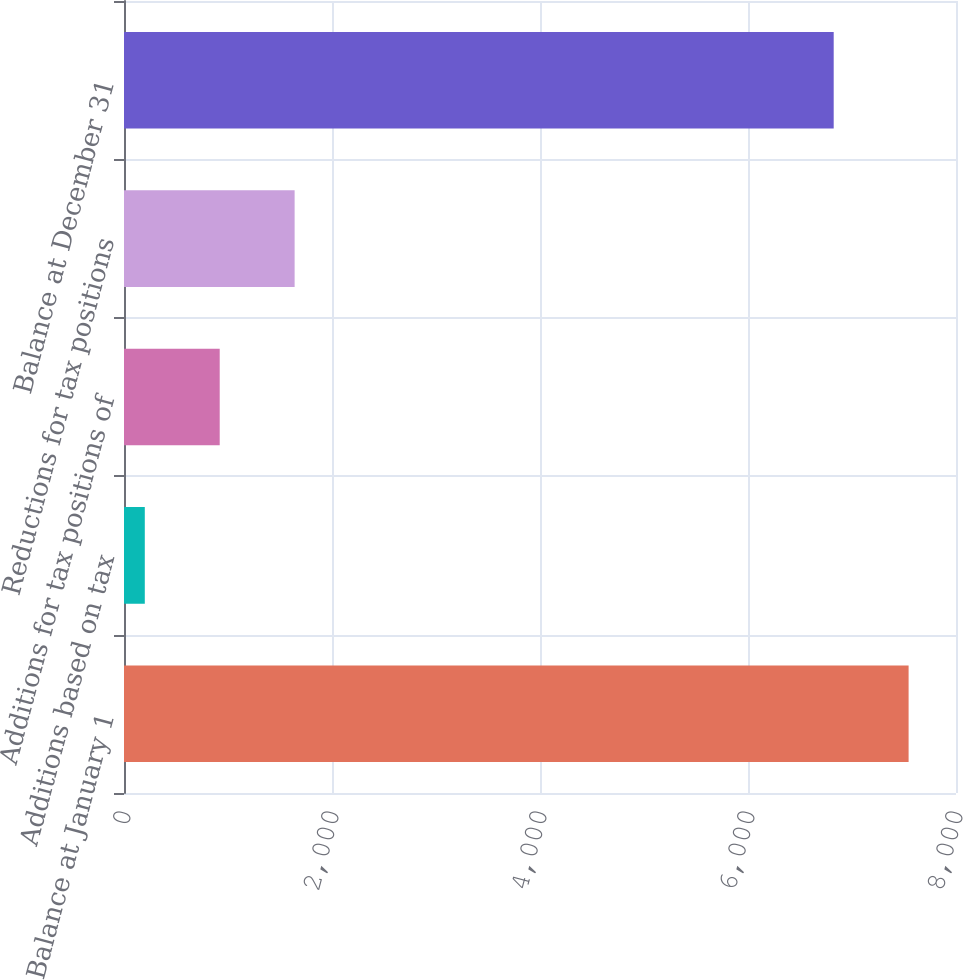Convert chart to OTSL. <chart><loc_0><loc_0><loc_500><loc_500><bar_chart><fcel>Balance at January 1<fcel>Additions based on tax<fcel>Additions for tax positions of<fcel>Reductions for tax positions<fcel>Balance at December 31<nl><fcel>7544.3<fcel>200<fcel>920.3<fcel>1640.6<fcel>6824<nl></chart> 